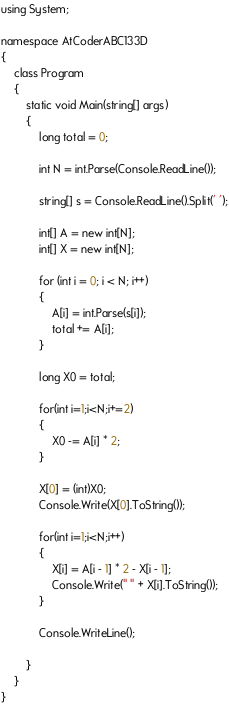Convert code to text. <code><loc_0><loc_0><loc_500><loc_500><_C#_>using System;

namespace AtCoderABC133D
{
    class Program
    {
        static void Main(string[] args)
        {
            long total = 0;

            int N = int.Parse(Console.ReadLine());

            string[] s = Console.ReadLine().Split(' ');

            int[] A = new int[N];
            int[] X = new int[N];

            for (int i = 0; i < N; i++)
            {
                A[i] = int.Parse(s[i]);
                total += A[i];
            }

            long X0 = total;

            for(int i=1;i<N;i+=2)
            {
                X0 -= A[i] * 2;
            }

            X[0] = (int)X0;
            Console.Write(X[0].ToString());

            for(int i=1;i<N;i++)
            {
                X[i] = A[i - 1] * 2 - X[i - 1];
                Console.Write(" " + X[i].ToString());
            }

            Console.WriteLine();
            
        }
    }
}
</code> 